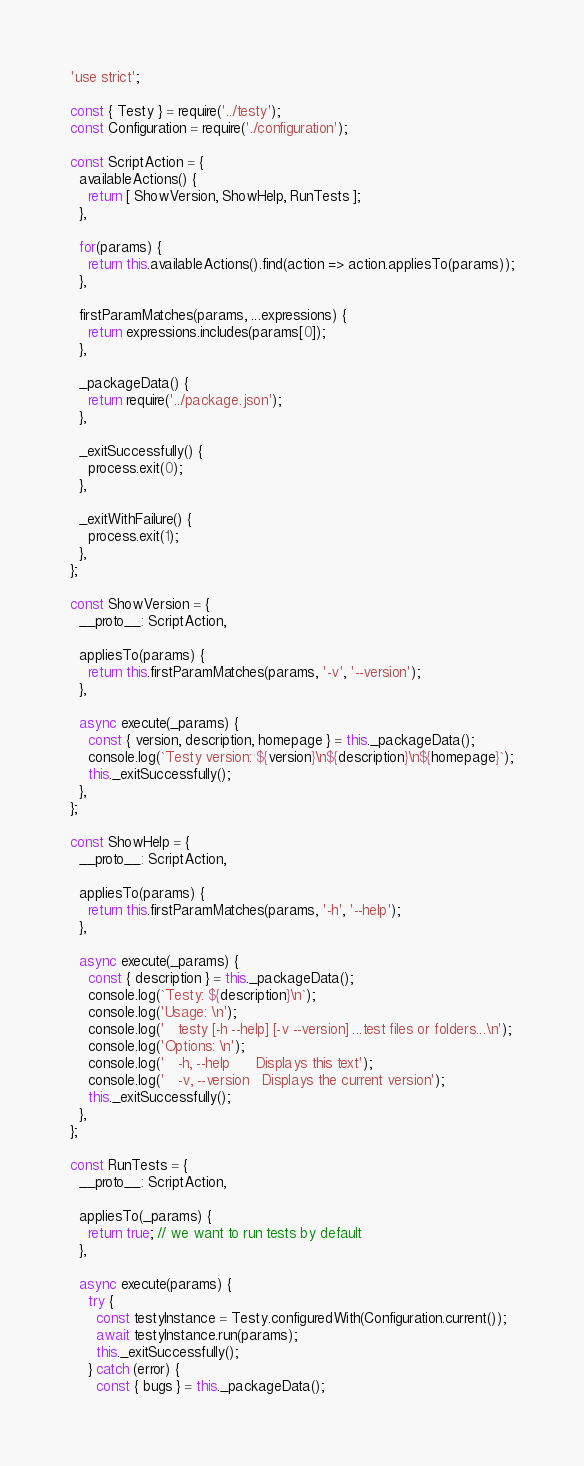Convert code to text. <code><loc_0><loc_0><loc_500><loc_500><_JavaScript_>'use strict';

const { Testy } = require('../testy');
const Configuration = require('./configuration');

const ScriptAction = {
  availableActions() {
    return [ ShowVersion, ShowHelp, RunTests ];
  },

  for(params) {
    return this.availableActions().find(action => action.appliesTo(params));
  },

  firstParamMatches(params, ...expressions) {
    return expressions.includes(params[0]);
  },

  _packageData() {
    return require('../package.json');
  },

  _exitSuccessfully() {
    process.exit(0);
  },

  _exitWithFailure() {
    process.exit(1);
  },
};

const ShowVersion = {
  __proto__: ScriptAction,

  appliesTo(params) {
    return this.firstParamMatches(params, '-v', '--version');
  },

  async execute(_params) {
    const { version, description, homepage } = this._packageData();
    console.log(`Testy version: ${version}\n${description}\n${homepage}`);
    this._exitSuccessfully();
  },
};

const ShowHelp = {
  __proto__: ScriptAction,

  appliesTo(params) {
    return this.firstParamMatches(params, '-h', '--help');
  },

  async execute(_params) {
    const { description } = this._packageData();
    console.log(`Testy: ${description}\n`);
    console.log('Usage: \n');
    console.log('   testy [-h --help] [-v --version] ...test files or folders...\n');
    console.log('Options: \n');
    console.log('   -h, --help      Displays this text');
    console.log('   -v, --version   Displays the current version');
    this._exitSuccessfully();
  },
};

const RunTests = {
  __proto__: ScriptAction,

  appliesTo(_params) {
    return true; // we want to run tests by default
  },

  async execute(params) {
    try {
      const testyInstance = Testy.configuredWith(Configuration.current());
      await testyInstance.run(params);
      this._exitSuccessfully();
    } catch (error) {
      const { bugs } = this._packageData();</code> 